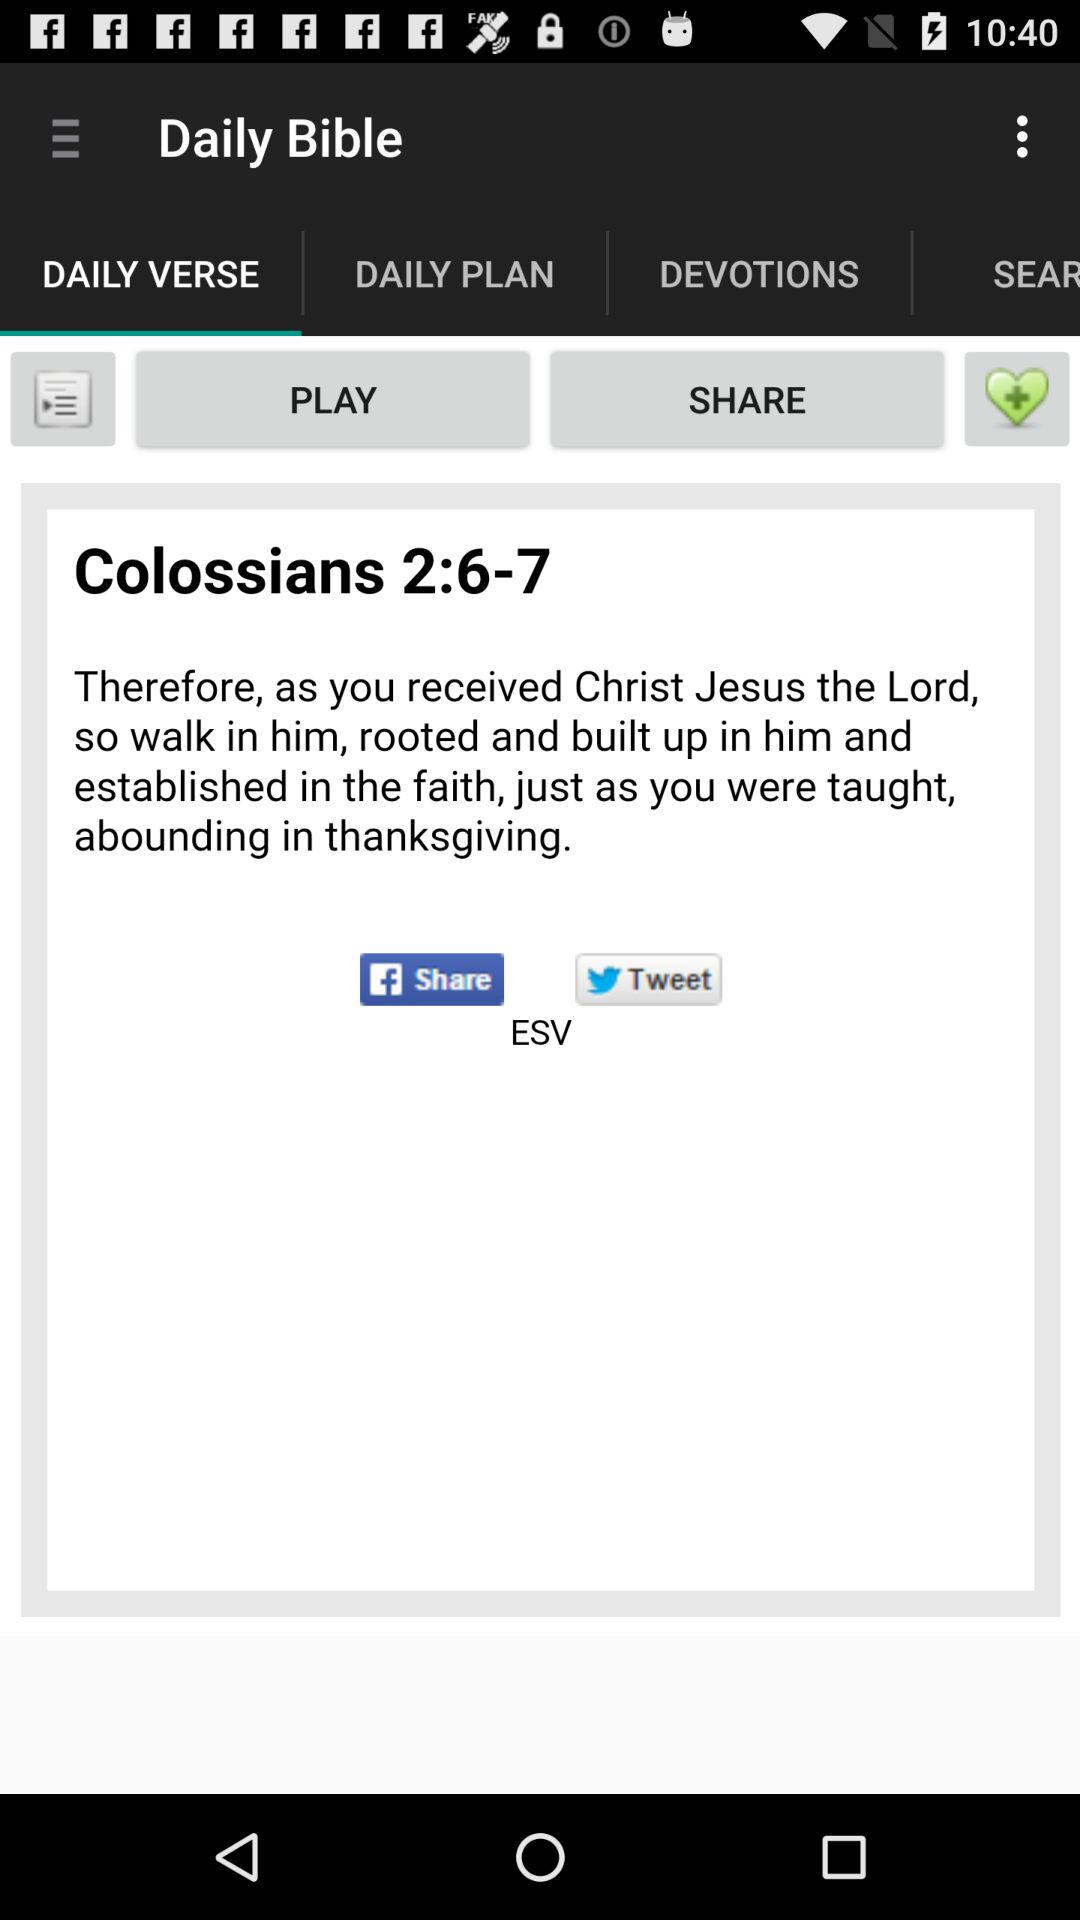What is the Bible verse number? The Bible verse numbers are 6 and 7. 